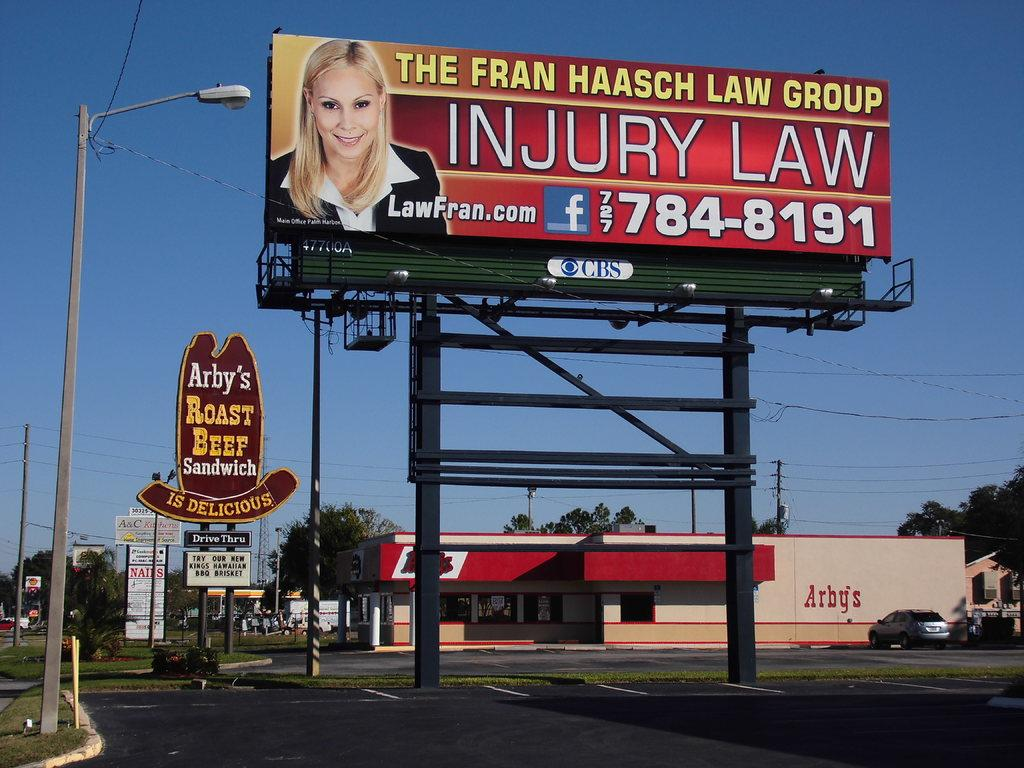<image>
Write a terse but informative summary of the picture. the words injury law are on the red billboard 